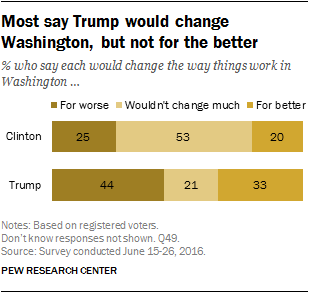Draw attention to some important aspects in this diagram. The value of the brown bar for Trump is 44. 